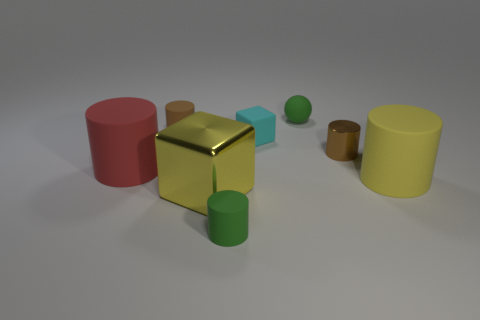Subtract 2 cylinders. How many cylinders are left? 3 Subtract all yellow cylinders. Subtract all purple spheres. How many cylinders are left? 4 Add 1 tiny rubber things. How many objects exist? 9 Subtract all spheres. How many objects are left? 7 Add 6 gray matte spheres. How many gray matte spheres exist? 6 Subtract 0 red balls. How many objects are left? 8 Subtract all small matte spheres. Subtract all brown things. How many objects are left? 5 Add 2 tiny cyan rubber blocks. How many tiny cyan rubber blocks are left? 3 